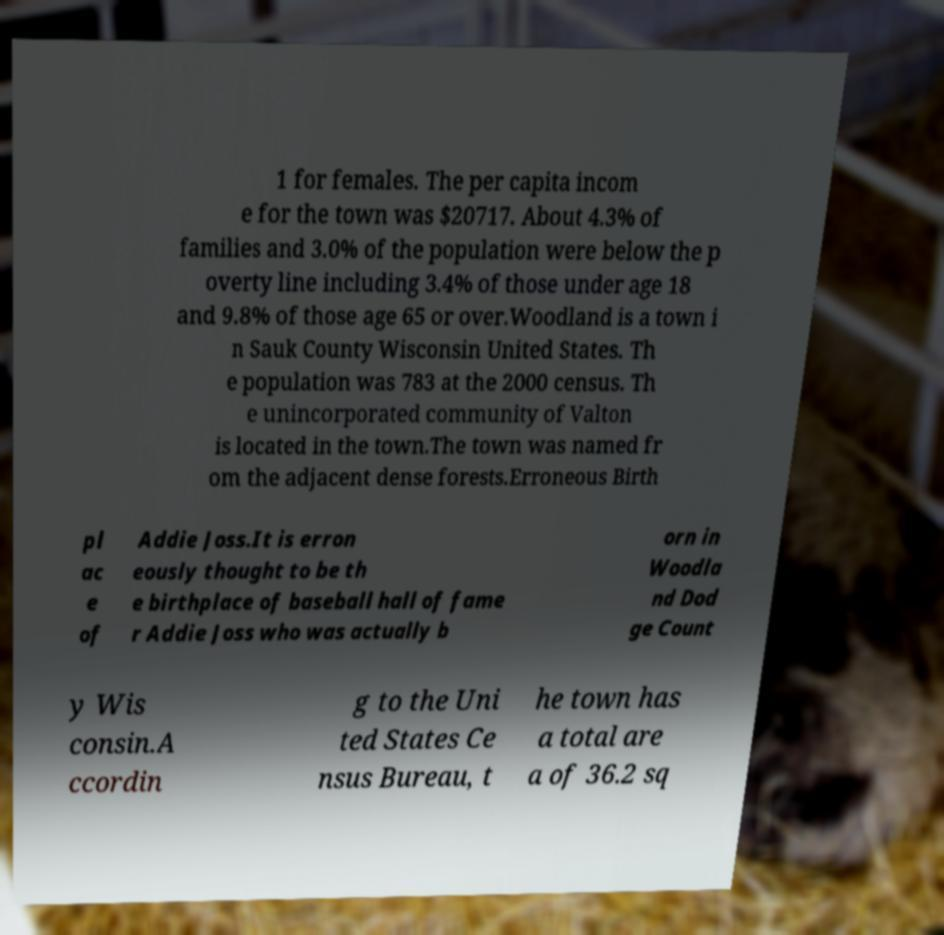For documentation purposes, I need the text within this image transcribed. Could you provide that? 1 for females. The per capita incom e for the town was $20717. About 4.3% of families and 3.0% of the population were below the p overty line including 3.4% of those under age 18 and 9.8% of those age 65 or over.Woodland is a town i n Sauk County Wisconsin United States. Th e population was 783 at the 2000 census. Th e unincorporated community of Valton is located in the town.The town was named fr om the adjacent dense forests.Erroneous Birth pl ac e of Addie Joss.It is erron eously thought to be th e birthplace of baseball hall of fame r Addie Joss who was actually b orn in Woodla nd Dod ge Count y Wis consin.A ccordin g to the Uni ted States Ce nsus Bureau, t he town has a total are a of 36.2 sq 